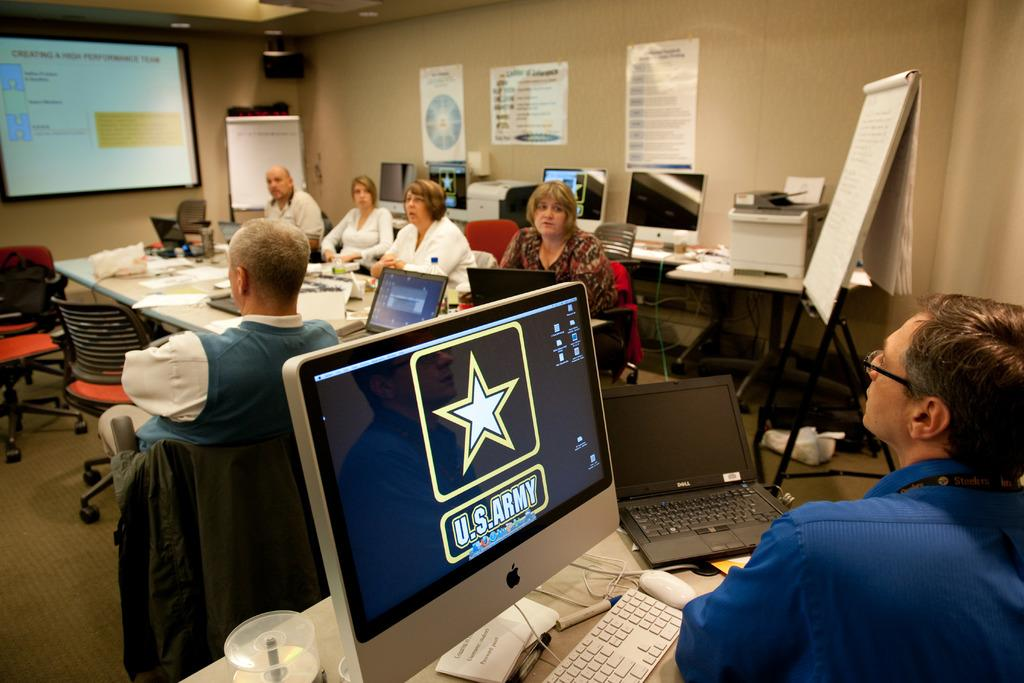<image>
Present a compact description of the photo's key features. A man is in front of a computer monitor with U.S. Army on it. 